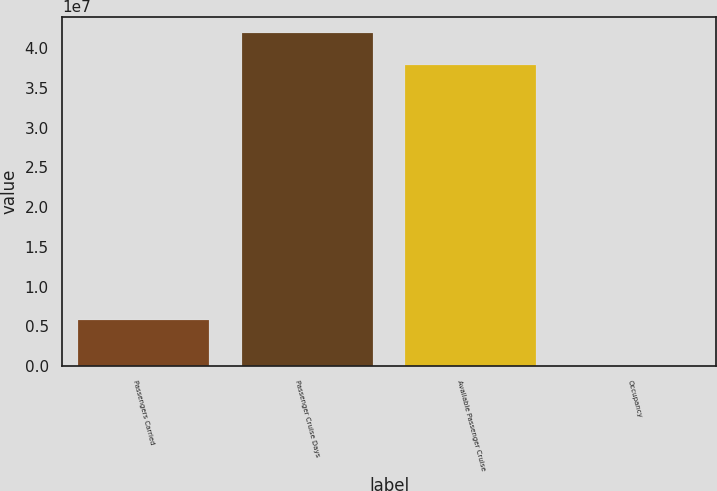<chart> <loc_0><loc_0><loc_500><loc_500><bar_chart><fcel>Passengers Carried<fcel>Passenger Cruise Days<fcel>Available Passenger Cruise<fcel>Occupancy<nl><fcel>5.75475e+06<fcel>4.18697e+07<fcel>3.78446e+07<fcel>106.4<nl></chart> 